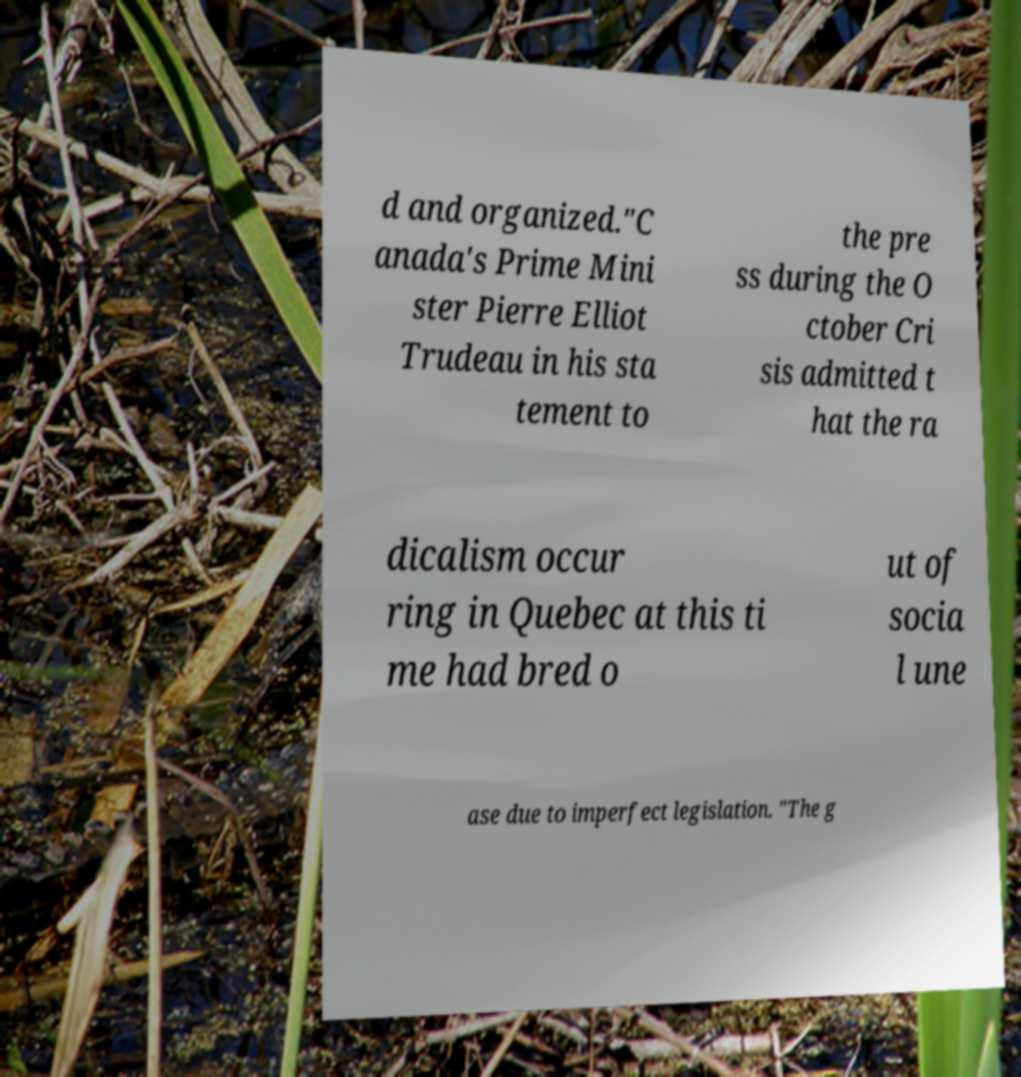There's text embedded in this image that I need extracted. Can you transcribe it verbatim? d and organized."C anada's Prime Mini ster Pierre Elliot Trudeau in his sta tement to the pre ss during the O ctober Cri sis admitted t hat the ra dicalism occur ring in Quebec at this ti me had bred o ut of socia l une ase due to imperfect legislation. "The g 